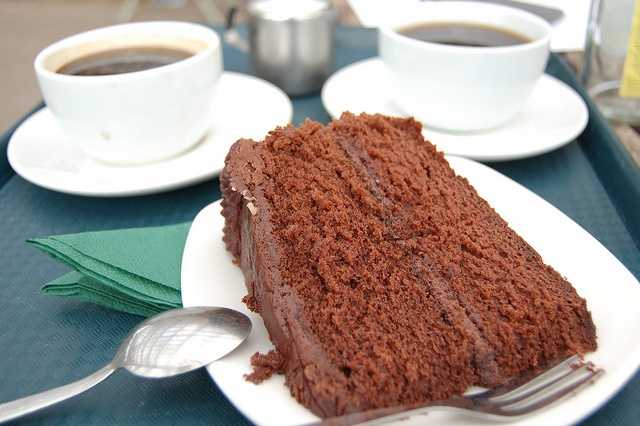Describe the objects in this image and their specific colors. I can see cake in tan, brown, and maroon tones, cup in tan, white, and darkgray tones, cup in tan, white, and darkgray tones, spoon in tan, lightgray, darkgray, and gray tones, and fork in tan, darkgray, gray, and lightgray tones in this image. 